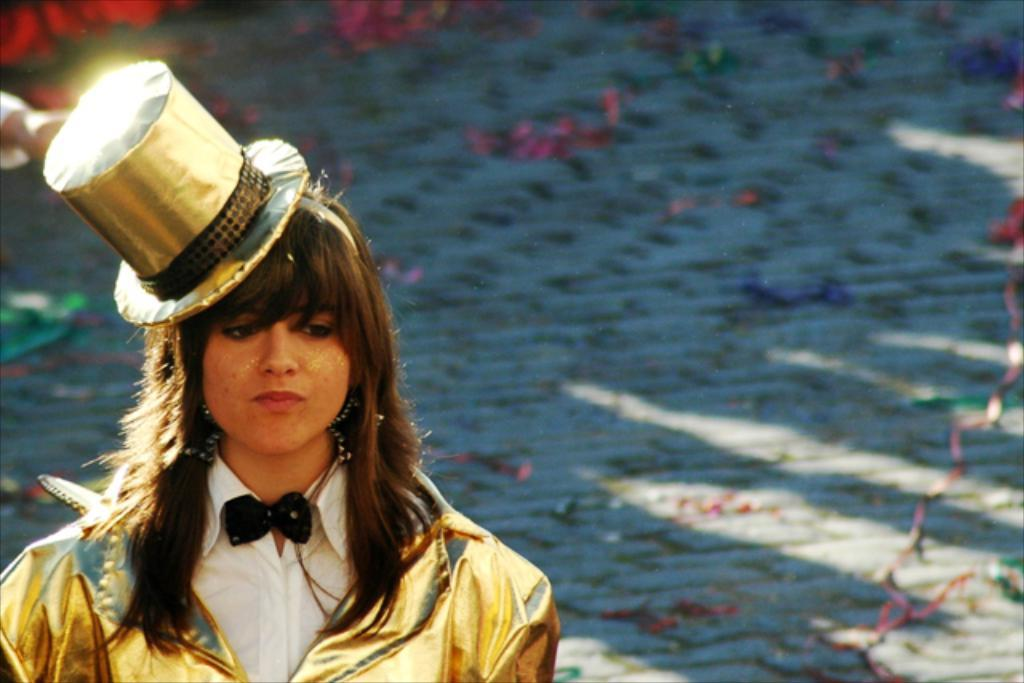Who is the main subject in the image? There is a lady in the image. What is the lady wearing on her head? The lady is wearing a hat. What accessory is the lady wearing around her neck? The lady has a bow tie on her neck. What type of surface is visible beneath the lady? There is a floor visible in the image. What can be seen on the floor in the image? There are items on the floor. Can you tell me how many flies are sitting on the lady's hat in the image? There are no flies present in the image, so it is not possible to determine how many might be sitting on the lady's hat. 